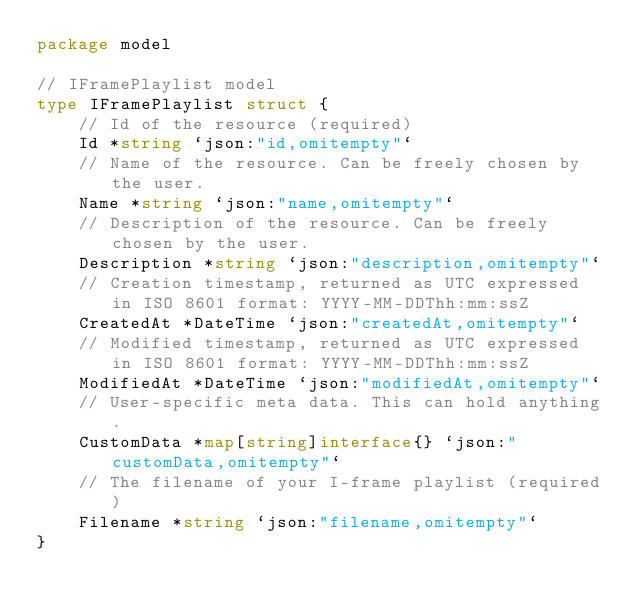<code> <loc_0><loc_0><loc_500><loc_500><_Go_>package model

// IFramePlaylist model
type IFramePlaylist struct {
	// Id of the resource (required)
	Id *string `json:"id,omitempty"`
	// Name of the resource. Can be freely chosen by the user.
	Name *string `json:"name,omitempty"`
	// Description of the resource. Can be freely chosen by the user.
	Description *string `json:"description,omitempty"`
	// Creation timestamp, returned as UTC expressed in ISO 8601 format: YYYY-MM-DDThh:mm:ssZ
	CreatedAt *DateTime `json:"createdAt,omitempty"`
	// Modified timestamp, returned as UTC expressed in ISO 8601 format: YYYY-MM-DDThh:mm:ssZ
	ModifiedAt *DateTime `json:"modifiedAt,omitempty"`
	// User-specific meta data. This can hold anything.
	CustomData *map[string]interface{} `json:"customData,omitempty"`
	// The filename of your I-frame playlist (required)
	Filename *string `json:"filename,omitempty"`
}
</code> 